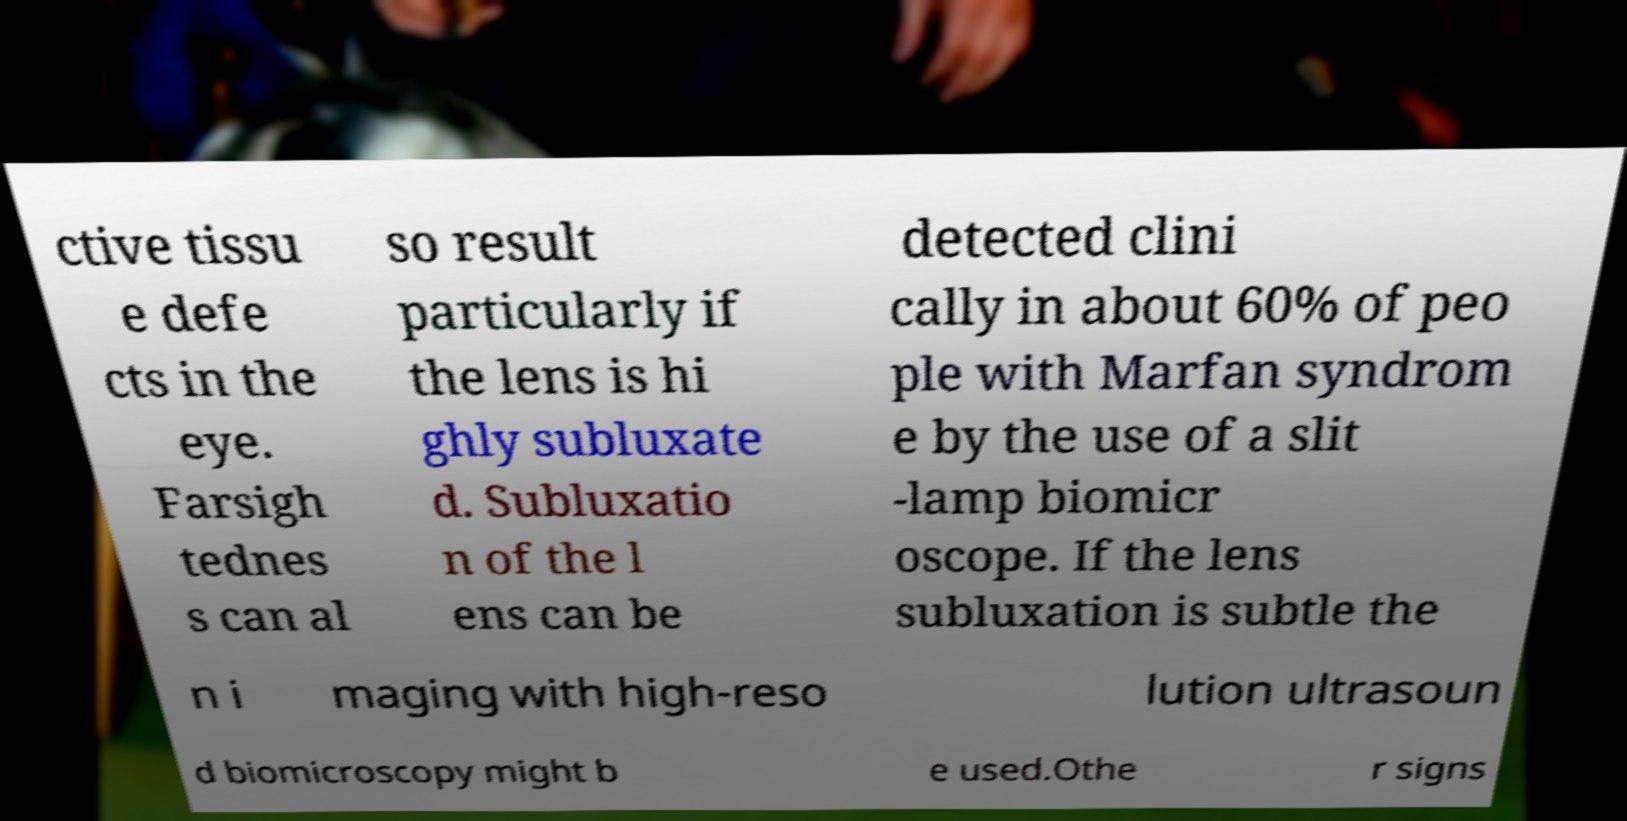For documentation purposes, I need the text within this image transcribed. Could you provide that? ctive tissu e defe cts in the eye. Farsigh tednes s can al so result particularly if the lens is hi ghly subluxate d. Subluxatio n of the l ens can be detected clini cally in about 60% of peo ple with Marfan syndrom e by the use of a slit -lamp biomicr oscope. If the lens subluxation is subtle the n i maging with high-reso lution ultrasoun d biomicroscopy might b e used.Othe r signs 